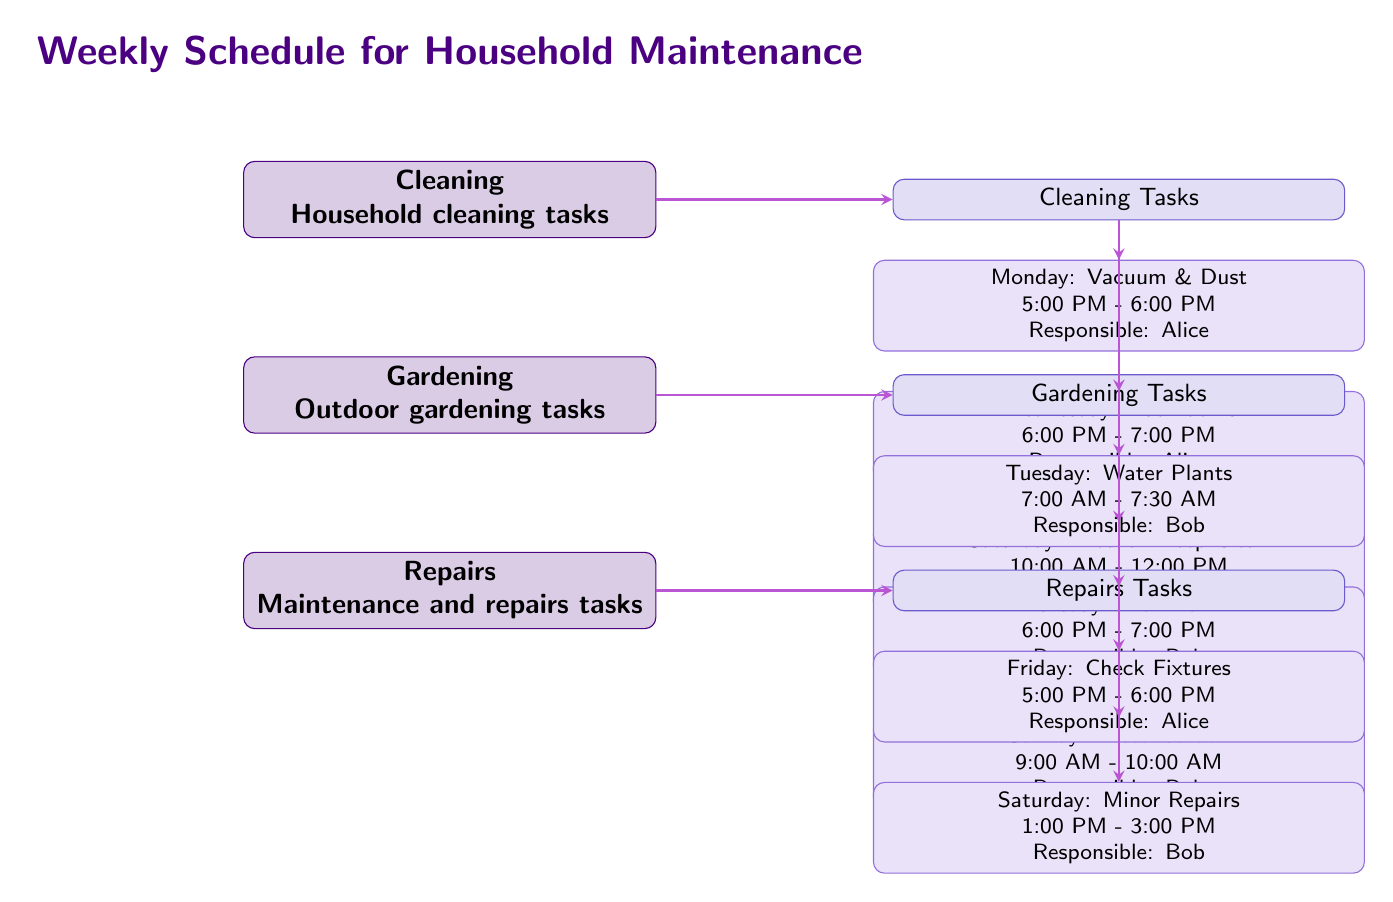What is the main category for household cleaning tasks? The diagram presents "Cleaning" as the primary node under "Weekly Schedule for Household Maintenance," indicating its main category.
Answer: Cleaning Who is responsible for watering the plants? The diagram shows that Bob is assigned the task of watering plants on Tuesday, indicated next to the task under Gardening.
Answer: Bob How many tasks are scheduled for cleaning? The diagram lists three specific cleaning tasks: Vacuum & Dust, Bathrooms, and Kitchen Deep Clean, providing a total of three tasks.
Answer: 3 What day is allocated for checking fixtures? The diagram states that checking fixtures is scheduled for Friday, where this specific task is detailed under Repairs.
Answer: Friday Which day features both cleaning and repairs tasks? The diagram shows that Saturday includes two tasks: one for cleaning (Kitchen Deep Clean) and one for repairs (Minor Repairs).
Answer: Saturday What is the time assigned for mowing the lawn? The diagram indicates that mowing the lawn is assigned to Thursday from 6:00 PM to 7:00 PM, as specified in the Gardening section.
Answer: 6:00 PM - 7:00 PM Who is assigned for minor repairs? The diagram indicates that Bob is responsible for the minor repairs task, scheduled for Saturday under Repairs.
Answer: Bob How many gardening tasks are outlined in the diagram? The diagram outlines three gardening tasks: Water Plants, Mow Lawn, and Weed Garden, providing a total of three tasks.
Answer: 3 On which day does Alice have a cleaning task scheduled? The diagram shows Alice has tasks scheduled on Monday (Vacuum & Dust), Wednesday (Bathrooms), and Friday (Check Fixtures).
Answer: Monday, Wednesday, Friday What color theme is used for the main category nodes? The diagram uses a main color defined as deep purple for the main category nodes, providing a clear visual distinction.
Answer: Maincolor 